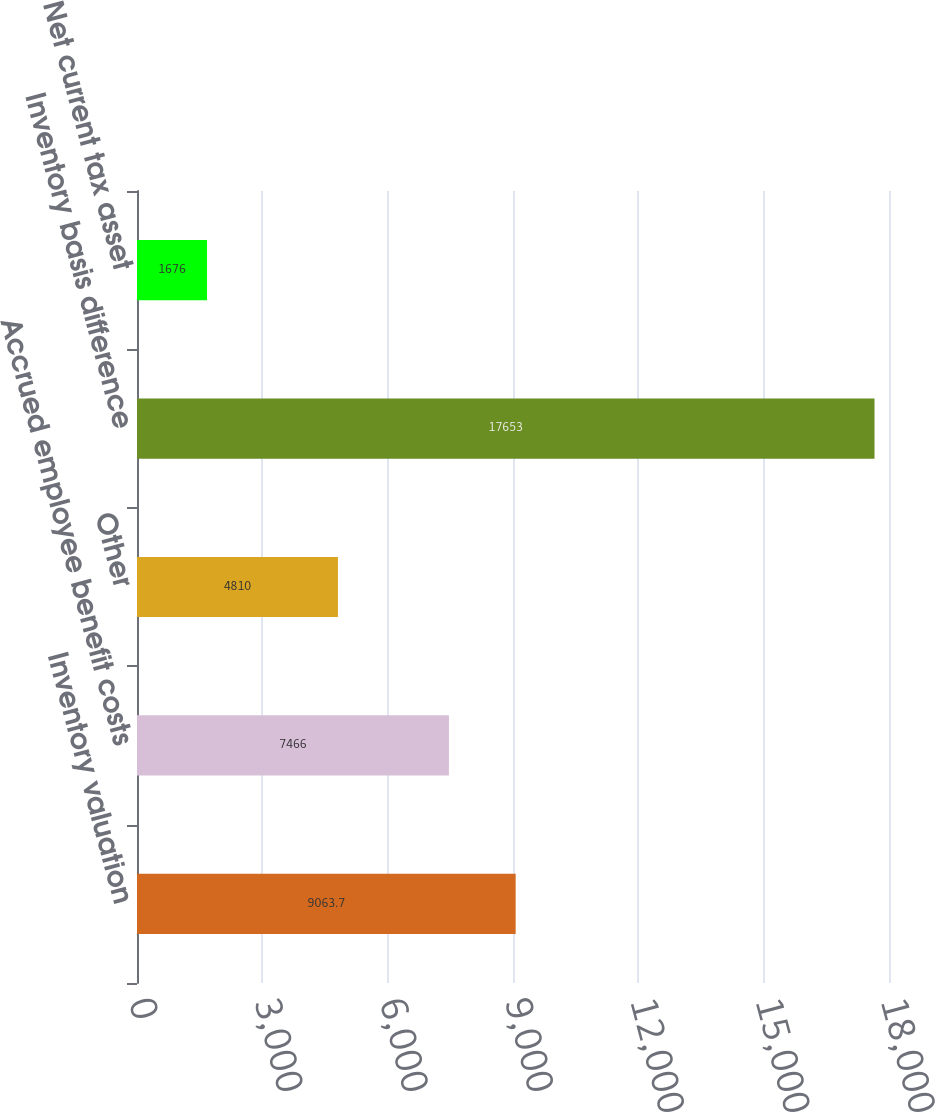<chart> <loc_0><loc_0><loc_500><loc_500><bar_chart><fcel>Inventory valuation<fcel>Accrued employee benefit costs<fcel>Other<fcel>Inventory basis difference<fcel>Net current tax asset<nl><fcel>9063.7<fcel>7466<fcel>4810<fcel>17653<fcel>1676<nl></chart> 